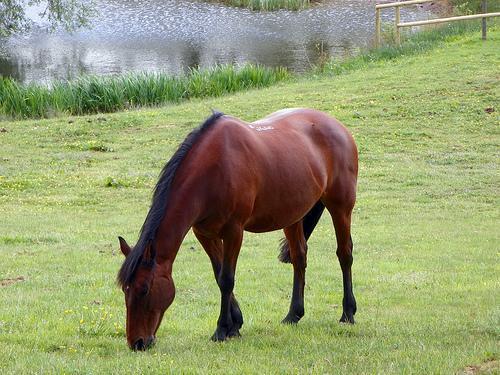How many horses are shown?
Give a very brief answer. 1. 